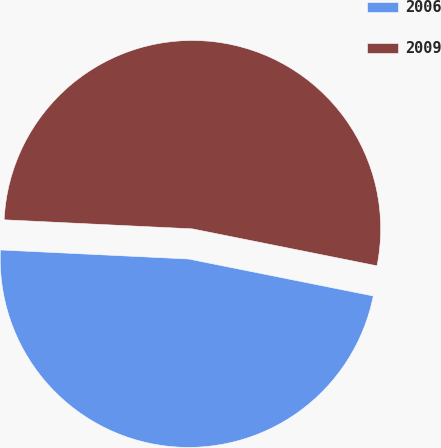<chart> <loc_0><loc_0><loc_500><loc_500><pie_chart><fcel>2006<fcel>2009<nl><fcel>47.62%<fcel>52.38%<nl></chart> 